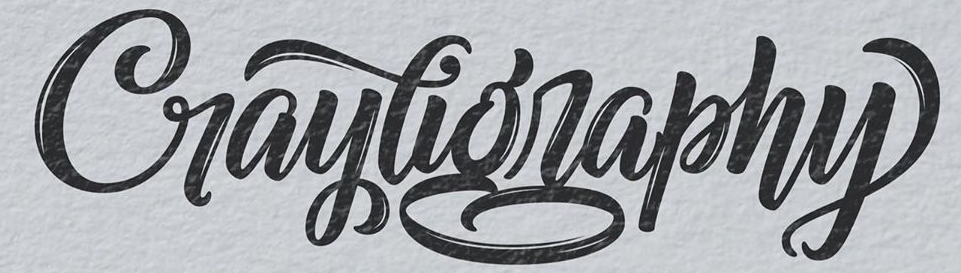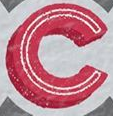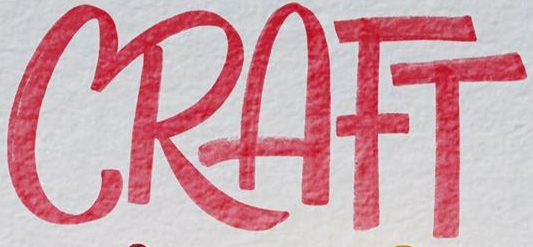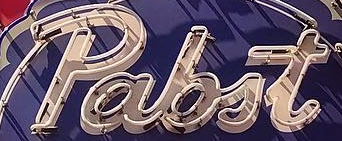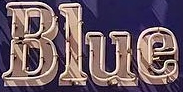What text is displayed in these images sequentially, separated by a semicolon? Craytigraphy; C; CRAFT; pabit; Blue 